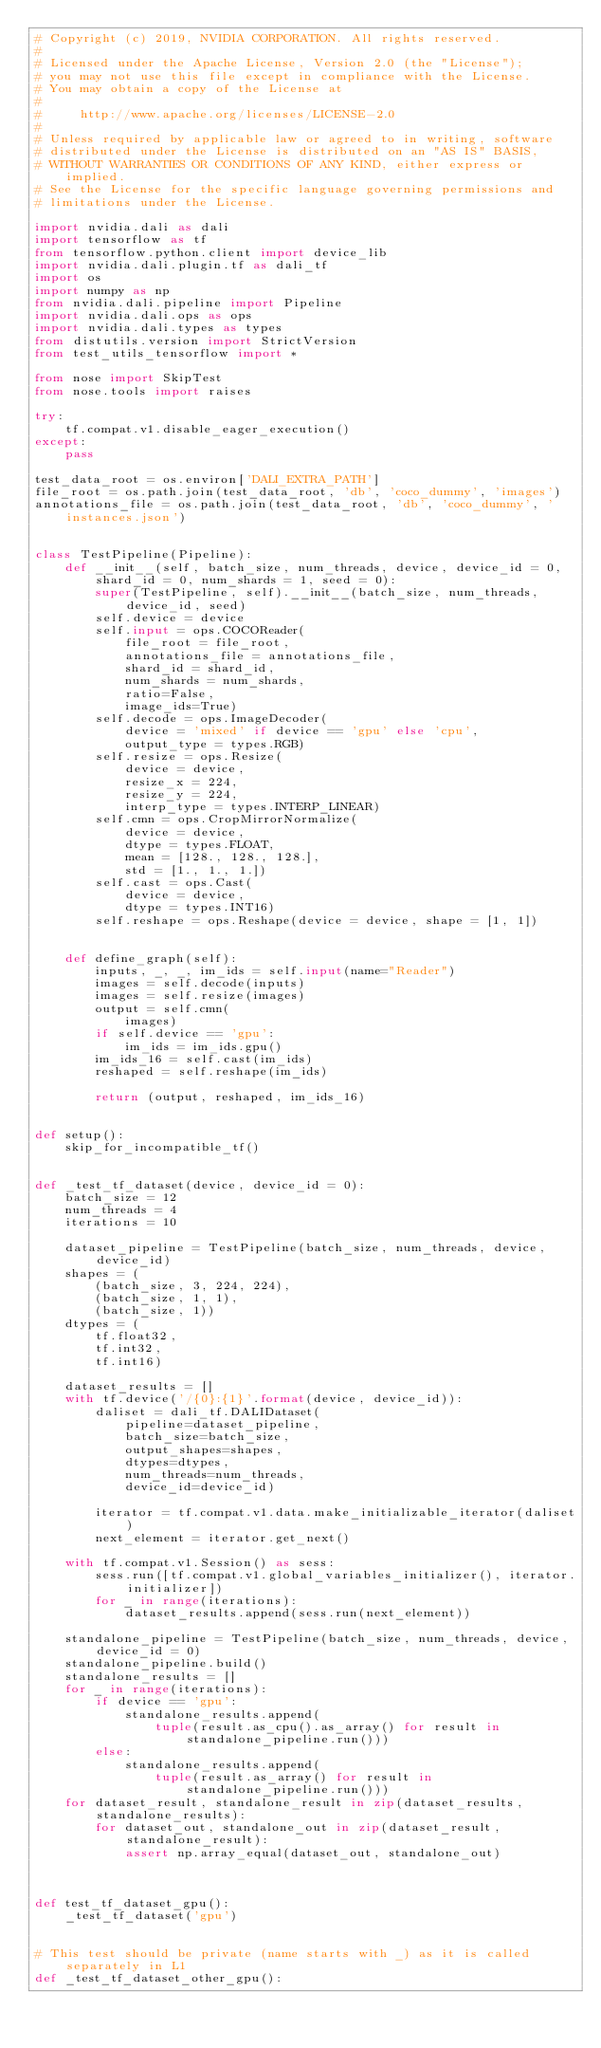Convert code to text. <code><loc_0><loc_0><loc_500><loc_500><_Python_># Copyright (c) 2019, NVIDIA CORPORATION. All rights reserved.
#
# Licensed under the Apache License, Version 2.0 (the "License");
# you may not use this file except in compliance with the License.
# You may obtain a copy of the License at
#
#     http://www.apache.org/licenses/LICENSE-2.0
#
# Unless required by applicable law or agreed to in writing, software
# distributed under the License is distributed on an "AS IS" BASIS,
# WITHOUT WARRANTIES OR CONDITIONS OF ANY KIND, either express or implied.
# See the License for the specific language governing permissions and
# limitations under the License.

import nvidia.dali as dali
import tensorflow as tf
from tensorflow.python.client import device_lib
import nvidia.dali.plugin.tf as dali_tf
import os
import numpy as np
from nvidia.dali.pipeline import Pipeline
import nvidia.dali.ops as ops
import nvidia.dali.types as types
from distutils.version import StrictVersion
from test_utils_tensorflow import *

from nose import SkipTest
from nose.tools import raises

try:
    tf.compat.v1.disable_eager_execution()
except:
    pass

test_data_root = os.environ['DALI_EXTRA_PATH']
file_root = os.path.join(test_data_root, 'db', 'coco_dummy', 'images')
annotations_file = os.path.join(test_data_root, 'db', 'coco_dummy', 'instances.json')


class TestPipeline(Pipeline):
    def __init__(self, batch_size, num_threads, device, device_id = 0, shard_id = 0, num_shards = 1, seed = 0):
        super(TestPipeline, self).__init__(batch_size, num_threads, device_id, seed)
        self.device = device
        self.input = ops.COCOReader(
            file_root = file_root,
            annotations_file = annotations_file,
            shard_id = shard_id,
            num_shards = num_shards,
            ratio=False,
            image_ids=True)
        self.decode = ops.ImageDecoder(
            device = 'mixed' if device == 'gpu' else 'cpu',
            output_type = types.RGB)
        self.resize = ops.Resize(
            device = device,
            resize_x = 224,
            resize_y = 224,
            interp_type = types.INTERP_LINEAR)
        self.cmn = ops.CropMirrorNormalize(
            device = device,
            dtype = types.FLOAT,
            mean = [128., 128., 128.],
            std = [1., 1., 1.])
        self.cast = ops.Cast(
            device = device,
            dtype = types.INT16)
        self.reshape = ops.Reshape(device = device, shape = [1, 1])


    def define_graph(self):
        inputs, _, _, im_ids = self.input(name="Reader")
        images = self.decode(inputs)
        images = self.resize(images)
        output = self.cmn(
            images)
        if self.device == 'gpu':
            im_ids = im_ids.gpu()
        im_ids_16 = self.cast(im_ids)
        reshaped = self.reshape(im_ids)

        return (output, reshaped, im_ids_16)


def setup():
    skip_for_incompatible_tf()


def _test_tf_dataset(device, device_id = 0):
    batch_size = 12
    num_threads = 4
    iterations = 10

    dataset_pipeline = TestPipeline(batch_size, num_threads, device, device_id)
    shapes = (
        (batch_size, 3, 224, 224),
        (batch_size, 1, 1),
        (batch_size, 1))
    dtypes = (
        tf.float32,
        tf.int32,
        tf.int16)

    dataset_results = []
    with tf.device('/{0}:{1}'.format(device, device_id)):
        daliset = dali_tf.DALIDataset(
            pipeline=dataset_pipeline,
            batch_size=batch_size,
            output_shapes=shapes,
            dtypes=dtypes,
            num_threads=num_threads,
            device_id=device_id)

        iterator = tf.compat.v1.data.make_initializable_iterator(daliset)
        next_element = iterator.get_next()

    with tf.compat.v1.Session() as sess:
        sess.run([tf.compat.v1.global_variables_initializer(), iterator.initializer])
        for _ in range(iterations):
            dataset_results.append(sess.run(next_element))

    standalone_pipeline = TestPipeline(batch_size, num_threads, device, device_id = 0)
    standalone_pipeline.build()
    standalone_results = []
    for _ in range(iterations):
        if device == 'gpu':
            standalone_results.append(
                tuple(result.as_cpu().as_array() for result in standalone_pipeline.run()))
        else:
            standalone_results.append(
                tuple(result.as_array() for result in standalone_pipeline.run()))
    for dataset_result, standalone_result in zip(dataset_results, standalone_results):
        for dataset_out, standalone_out in zip(dataset_result, standalone_result):
            assert np.array_equal(dataset_out, standalone_out)



def test_tf_dataset_gpu():
    _test_tf_dataset('gpu')


# This test should be private (name starts with _) as it is called separately in L1
def _test_tf_dataset_other_gpu():</code> 